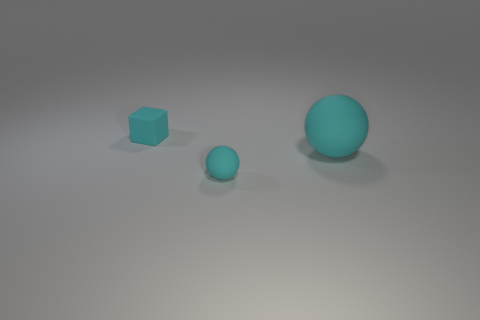There is a large sphere that is the same color as the tiny cube; what material is it?
Keep it short and to the point. Rubber. What size is the object that is behind the ball to the right of the tiny rubber sphere?
Your answer should be compact. Small. Is there a cube made of the same material as the big cyan sphere?
Your answer should be very brief. Yes. What is the material of the thing that is the same size as the rubber cube?
Offer a very short reply. Rubber. Does the tiny thing that is in front of the cyan rubber block have the same color as the object behind the large cyan matte object?
Your answer should be compact. Yes. There is a ball left of the large thing; is there a small rubber object left of it?
Offer a very short reply. Yes. There is a tiny thing on the right side of the tiny rubber block; is its shape the same as the big cyan thing in front of the small cube?
Keep it short and to the point. Yes. Do the small thing on the right side of the cyan rubber cube and the big thing that is right of the tiny cyan rubber block have the same material?
Make the answer very short. Yes. What material is the thing that is on the left side of the tiny cyan matte thing to the right of the matte block?
Provide a short and direct response. Rubber. There is a tiny object behind the cyan sphere that is on the right side of the matte sphere that is left of the large cyan rubber thing; what shape is it?
Ensure brevity in your answer.  Cube. 